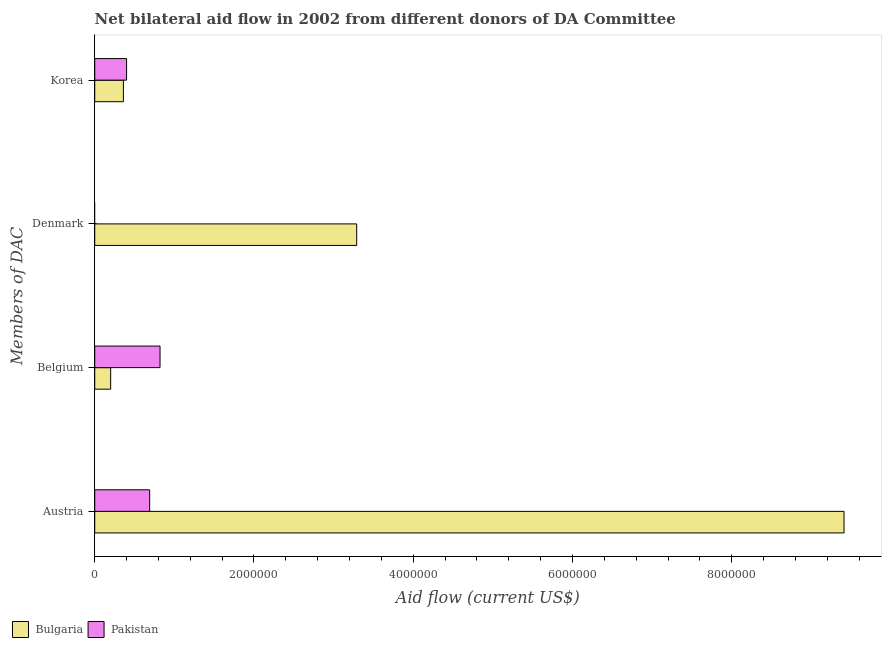How many bars are there on the 2nd tick from the bottom?
Offer a terse response. 2. What is the amount of aid given by belgium in Pakistan?
Provide a succinct answer. 8.20e+05. Across all countries, what is the maximum amount of aid given by korea?
Keep it short and to the point. 4.00e+05. What is the total amount of aid given by korea in the graph?
Offer a very short reply. 7.60e+05. What is the difference between the amount of aid given by korea in Bulgaria and that in Pakistan?
Make the answer very short. -4.00e+04. What is the difference between the amount of aid given by austria in Bulgaria and the amount of aid given by denmark in Pakistan?
Ensure brevity in your answer.  9.41e+06. What is the average amount of aid given by austria per country?
Give a very brief answer. 5.05e+06. What is the difference between the amount of aid given by austria and amount of aid given by belgium in Bulgaria?
Keep it short and to the point. 9.21e+06. In how many countries, is the amount of aid given by austria greater than 1200000 US$?
Offer a terse response. 1. What is the ratio of the amount of aid given by austria in Bulgaria to that in Pakistan?
Provide a succinct answer. 13.64. Is the amount of aid given by austria in Bulgaria less than that in Pakistan?
Ensure brevity in your answer.  No. What is the difference between the highest and the second highest amount of aid given by korea?
Ensure brevity in your answer.  4.00e+04. What is the difference between the highest and the lowest amount of aid given by austria?
Provide a succinct answer. 8.72e+06. Is it the case that in every country, the sum of the amount of aid given by belgium and amount of aid given by austria is greater than the sum of amount of aid given by korea and amount of aid given by denmark?
Offer a very short reply. No. How many bars are there?
Make the answer very short. 7. Are all the bars in the graph horizontal?
Give a very brief answer. Yes. How many countries are there in the graph?
Provide a short and direct response. 2. Are the values on the major ticks of X-axis written in scientific E-notation?
Provide a succinct answer. No. How many legend labels are there?
Provide a short and direct response. 2. What is the title of the graph?
Offer a terse response. Net bilateral aid flow in 2002 from different donors of DA Committee. Does "Tunisia" appear as one of the legend labels in the graph?
Provide a succinct answer. No. What is the label or title of the Y-axis?
Provide a succinct answer. Members of DAC. What is the Aid flow (current US$) of Bulgaria in Austria?
Provide a short and direct response. 9.41e+06. What is the Aid flow (current US$) in Pakistan in Austria?
Your answer should be very brief. 6.90e+05. What is the Aid flow (current US$) of Bulgaria in Belgium?
Offer a terse response. 2.00e+05. What is the Aid flow (current US$) of Pakistan in Belgium?
Your answer should be compact. 8.20e+05. What is the Aid flow (current US$) of Bulgaria in Denmark?
Your answer should be compact. 3.29e+06. What is the Aid flow (current US$) in Pakistan in Denmark?
Your response must be concise. 0. What is the Aid flow (current US$) in Bulgaria in Korea?
Your response must be concise. 3.60e+05. Across all Members of DAC, what is the maximum Aid flow (current US$) of Bulgaria?
Offer a terse response. 9.41e+06. Across all Members of DAC, what is the maximum Aid flow (current US$) of Pakistan?
Ensure brevity in your answer.  8.20e+05. Across all Members of DAC, what is the minimum Aid flow (current US$) in Pakistan?
Your answer should be compact. 0. What is the total Aid flow (current US$) in Bulgaria in the graph?
Provide a short and direct response. 1.33e+07. What is the total Aid flow (current US$) of Pakistan in the graph?
Your answer should be very brief. 1.91e+06. What is the difference between the Aid flow (current US$) in Bulgaria in Austria and that in Belgium?
Your response must be concise. 9.21e+06. What is the difference between the Aid flow (current US$) of Pakistan in Austria and that in Belgium?
Your answer should be very brief. -1.30e+05. What is the difference between the Aid flow (current US$) of Bulgaria in Austria and that in Denmark?
Offer a very short reply. 6.12e+06. What is the difference between the Aid flow (current US$) of Bulgaria in Austria and that in Korea?
Keep it short and to the point. 9.05e+06. What is the difference between the Aid flow (current US$) of Bulgaria in Belgium and that in Denmark?
Your response must be concise. -3.09e+06. What is the difference between the Aid flow (current US$) of Bulgaria in Belgium and that in Korea?
Provide a short and direct response. -1.60e+05. What is the difference between the Aid flow (current US$) in Bulgaria in Denmark and that in Korea?
Offer a very short reply. 2.93e+06. What is the difference between the Aid flow (current US$) in Bulgaria in Austria and the Aid flow (current US$) in Pakistan in Belgium?
Your answer should be compact. 8.59e+06. What is the difference between the Aid flow (current US$) in Bulgaria in Austria and the Aid flow (current US$) in Pakistan in Korea?
Ensure brevity in your answer.  9.01e+06. What is the difference between the Aid flow (current US$) in Bulgaria in Denmark and the Aid flow (current US$) in Pakistan in Korea?
Your answer should be compact. 2.89e+06. What is the average Aid flow (current US$) of Bulgaria per Members of DAC?
Your response must be concise. 3.32e+06. What is the average Aid flow (current US$) in Pakistan per Members of DAC?
Keep it short and to the point. 4.78e+05. What is the difference between the Aid flow (current US$) in Bulgaria and Aid flow (current US$) in Pakistan in Austria?
Provide a succinct answer. 8.72e+06. What is the difference between the Aid flow (current US$) in Bulgaria and Aid flow (current US$) in Pakistan in Belgium?
Provide a succinct answer. -6.20e+05. What is the ratio of the Aid flow (current US$) in Bulgaria in Austria to that in Belgium?
Ensure brevity in your answer.  47.05. What is the ratio of the Aid flow (current US$) of Pakistan in Austria to that in Belgium?
Make the answer very short. 0.84. What is the ratio of the Aid flow (current US$) of Bulgaria in Austria to that in Denmark?
Offer a very short reply. 2.86. What is the ratio of the Aid flow (current US$) of Bulgaria in Austria to that in Korea?
Your answer should be compact. 26.14. What is the ratio of the Aid flow (current US$) of Pakistan in Austria to that in Korea?
Offer a very short reply. 1.73. What is the ratio of the Aid flow (current US$) of Bulgaria in Belgium to that in Denmark?
Provide a short and direct response. 0.06. What is the ratio of the Aid flow (current US$) in Bulgaria in Belgium to that in Korea?
Provide a succinct answer. 0.56. What is the ratio of the Aid flow (current US$) in Pakistan in Belgium to that in Korea?
Your answer should be compact. 2.05. What is the ratio of the Aid flow (current US$) in Bulgaria in Denmark to that in Korea?
Your answer should be compact. 9.14. What is the difference between the highest and the second highest Aid flow (current US$) of Bulgaria?
Your answer should be very brief. 6.12e+06. What is the difference between the highest and the second highest Aid flow (current US$) in Pakistan?
Make the answer very short. 1.30e+05. What is the difference between the highest and the lowest Aid flow (current US$) of Bulgaria?
Your response must be concise. 9.21e+06. What is the difference between the highest and the lowest Aid flow (current US$) in Pakistan?
Your answer should be compact. 8.20e+05. 